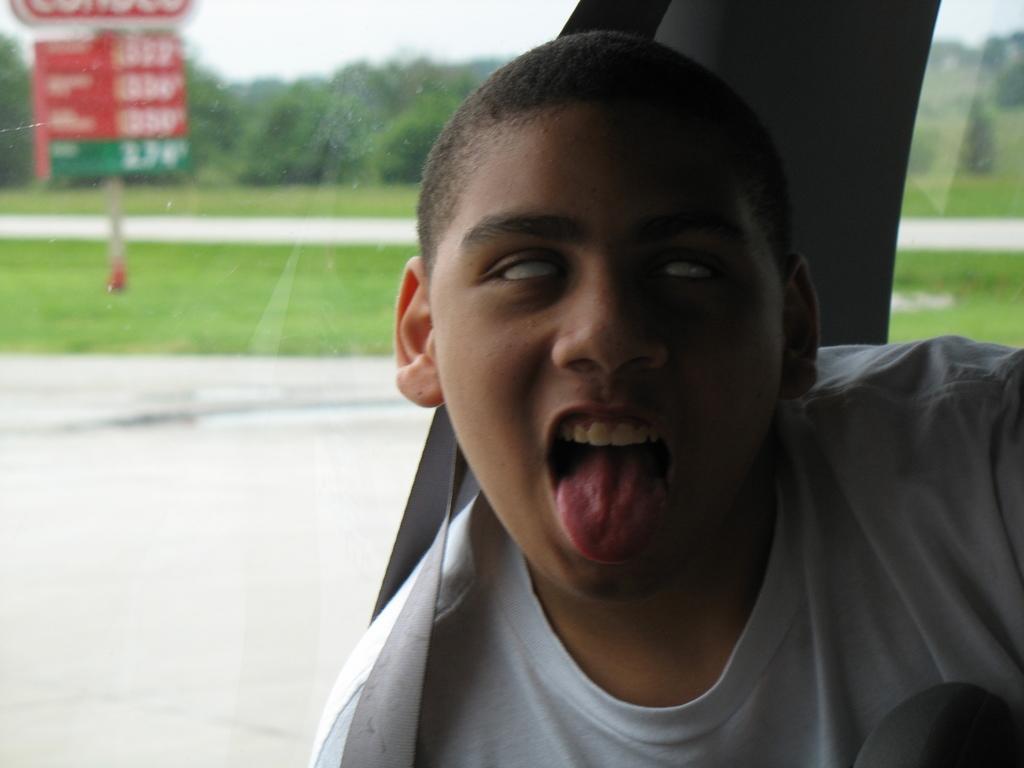How would you summarize this image in a sentence or two? In this image, we can see a boy is open his tongue and he is inside the vehicle. Here we can see a seat belt. Background there is a glass window. Through the glass window we can see the outside view. Here we can see grass, sign boards with pole, so many trees and road. 